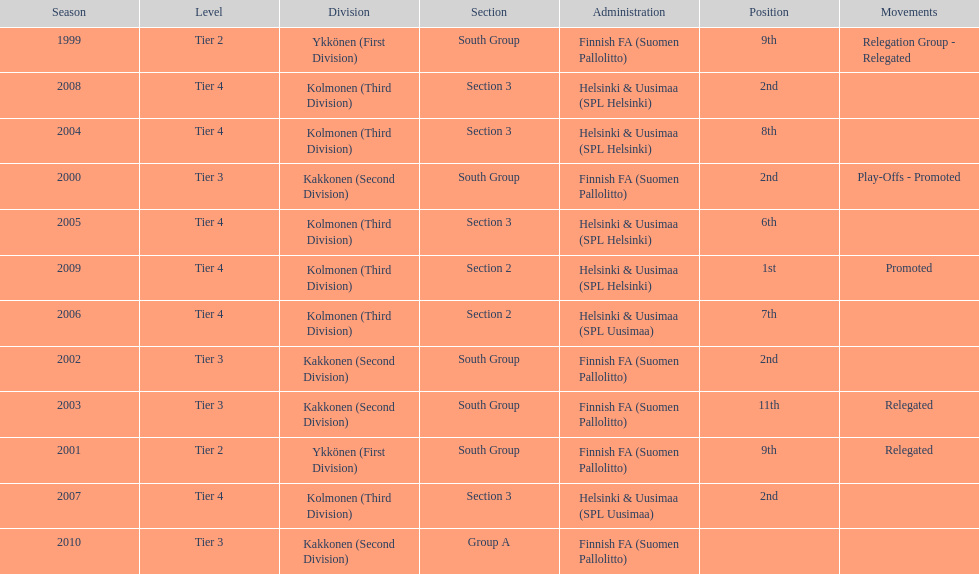How many continuous times did they engage in tier 4? 6. 